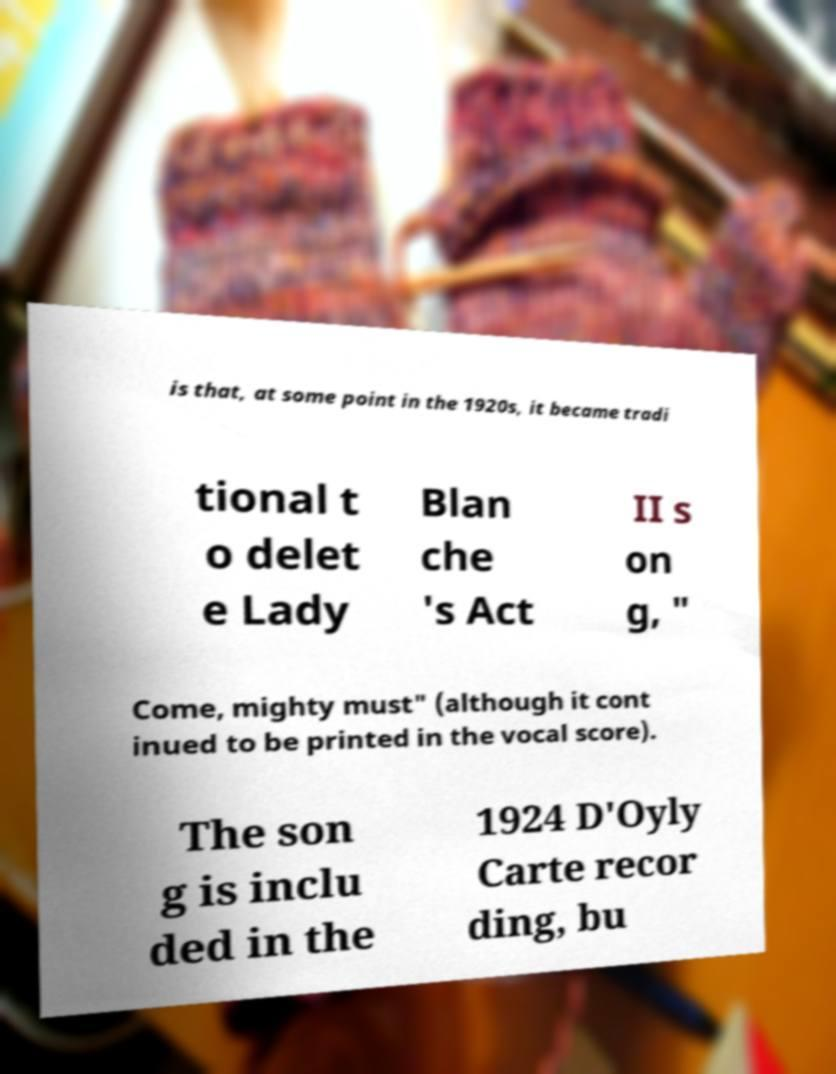Could you assist in decoding the text presented in this image and type it out clearly? is that, at some point in the 1920s, it became tradi tional t o delet e Lady Blan che 's Act II s on g, " Come, mighty must" (although it cont inued to be printed in the vocal score). The son g is inclu ded in the 1924 D'Oyly Carte recor ding, bu 